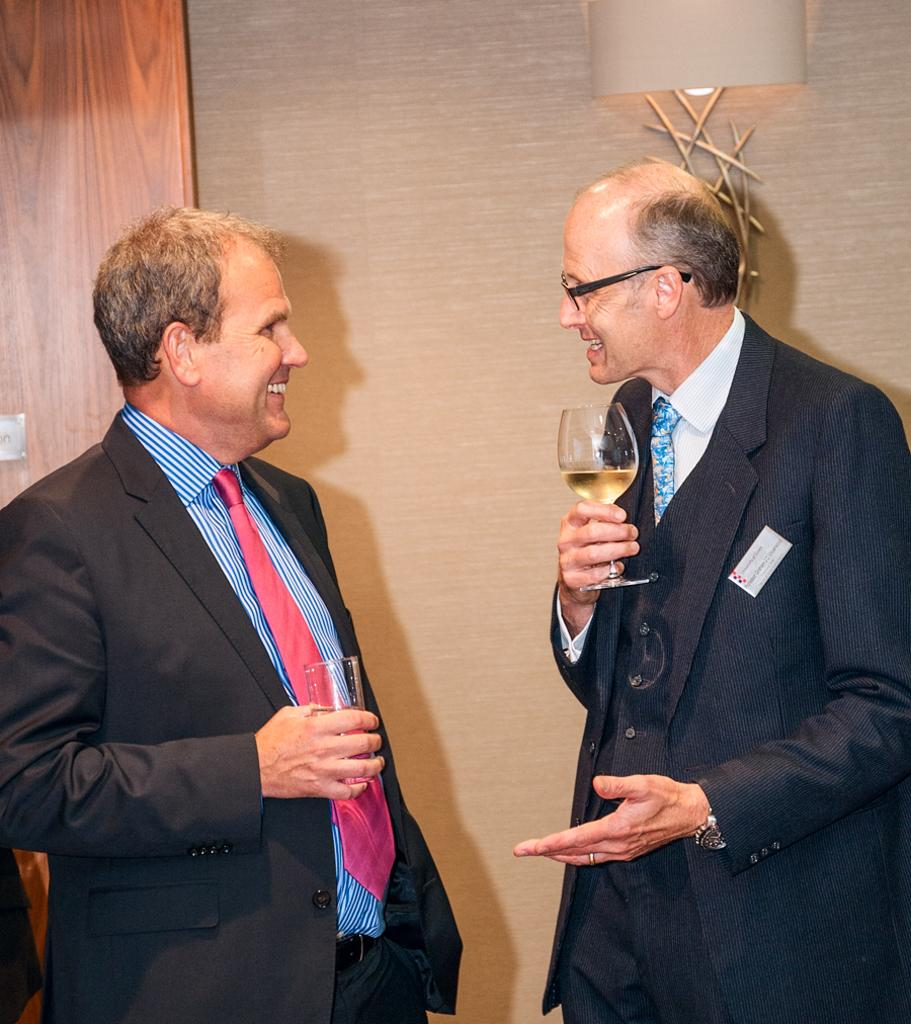How many people are in the image? There are two old men in the image. What are the old men holding in their hands? The old men are holding glasses of wine. What activity are the old men engaged in? The old men are speaking to each other. Can you describe any objects in the image besides the old men? There is a lamp present in the image, located in the top right corner. What type of hat is the old man wearing in the image? There is no hat present in the image; the old men are not wearing any hats. 